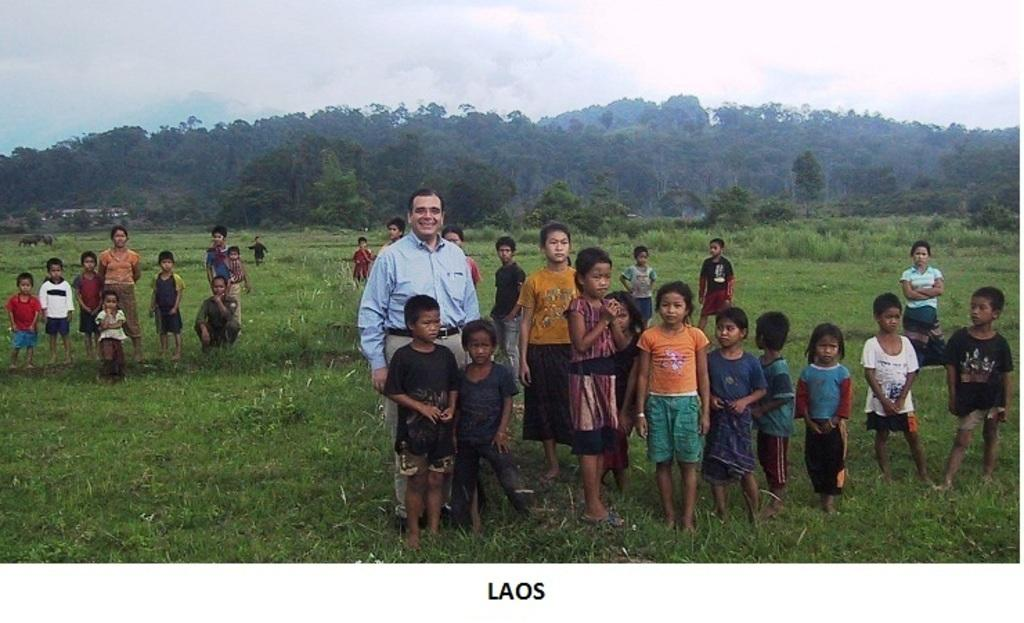What can be seen at the top of the image? The sky with clouds is visible at the top of the image. What type of natural elements are present in the image? There are trees in the image. What type of man-made structures can be seen in the image? There are buildings in the image. What type of living organisms are present in the image besides humans? Animals are present in the image. What is the ground surface like at the bottom of the image? People are standing on the grass at the bottom of the image. What color is the ink used to draw the clouds in the image? There is no ink present in the image, as the clouds are a natural part of the sky. How many minutes does it take for the people to walk from the buildings to the trees in the image? The image does not provide information about the distance between the buildings and trees, nor does it indicate any movement or time frame for the people. 